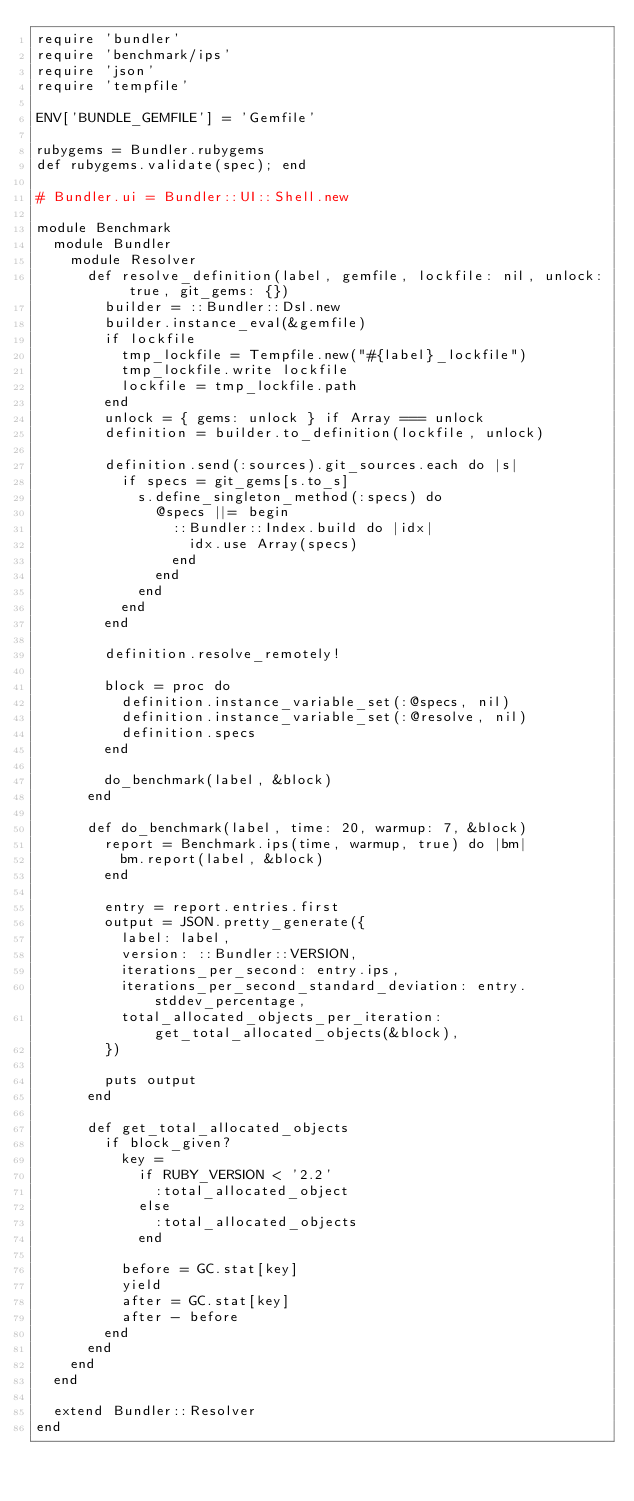<code> <loc_0><loc_0><loc_500><loc_500><_Ruby_>require 'bundler'
require 'benchmark/ips'
require 'json'
require 'tempfile'

ENV['BUNDLE_GEMFILE'] = 'Gemfile'

rubygems = Bundler.rubygems
def rubygems.validate(spec); end

# Bundler.ui = Bundler::UI::Shell.new

module Benchmark
  module Bundler
    module Resolver
      def resolve_definition(label, gemfile, lockfile: nil, unlock: true, git_gems: {})
        builder = ::Bundler::Dsl.new
        builder.instance_eval(&gemfile)
        if lockfile
          tmp_lockfile = Tempfile.new("#{label}_lockfile")
          tmp_lockfile.write lockfile
          lockfile = tmp_lockfile.path
        end
        unlock = { gems: unlock } if Array === unlock
        definition = builder.to_definition(lockfile, unlock)

        definition.send(:sources).git_sources.each do |s|
          if specs = git_gems[s.to_s]
            s.define_singleton_method(:specs) do
              @specs ||= begin
                ::Bundler::Index.build do |idx|
                  idx.use Array(specs)
                end
              end
            end
          end
        end

        definition.resolve_remotely!

        block = proc do
          definition.instance_variable_set(:@specs, nil)
          definition.instance_variable_set(:@resolve, nil)
          definition.specs
        end

        do_benchmark(label, &block)
      end

      def do_benchmark(label, time: 20, warmup: 7, &block)
        report = Benchmark.ips(time, warmup, true) do |bm|
          bm.report(label, &block)
        end

        entry = report.entries.first
        output = JSON.pretty_generate({
          label: label,
          version: ::Bundler::VERSION,
          iterations_per_second: entry.ips,
          iterations_per_second_standard_deviation: entry.stddev_percentage,
          total_allocated_objects_per_iteration: get_total_allocated_objects(&block),
        })

        puts output
      end

      def get_total_allocated_objects
        if block_given?
          key =
            if RUBY_VERSION < '2.2'
              :total_allocated_object
            else
              :total_allocated_objects
            end

          before = GC.stat[key]
          yield
          after = GC.stat[key]
          after - before
        end
      end
    end
  end

  extend Bundler::Resolver
end
</code> 